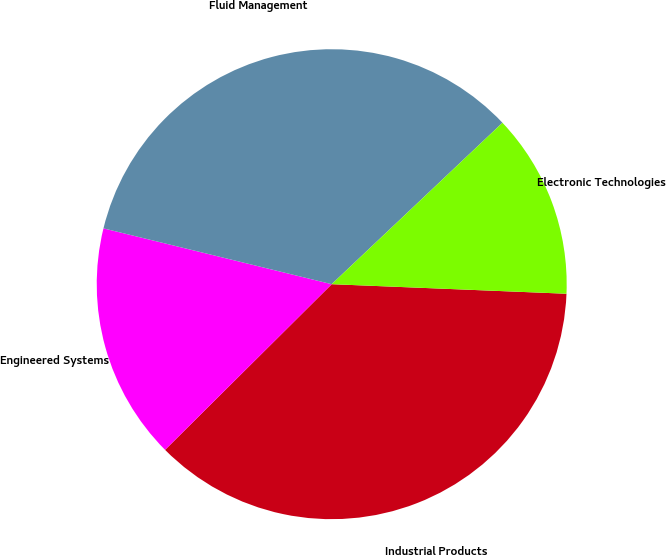<chart> <loc_0><loc_0><loc_500><loc_500><pie_chart><fcel>Industrial Products<fcel>Engineered Systems<fcel>Fluid Management<fcel>Electronic Technologies<nl><fcel>36.9%<fcel>16.27%<fcel>34.13%<fcel>12.7%<nl></chart> 